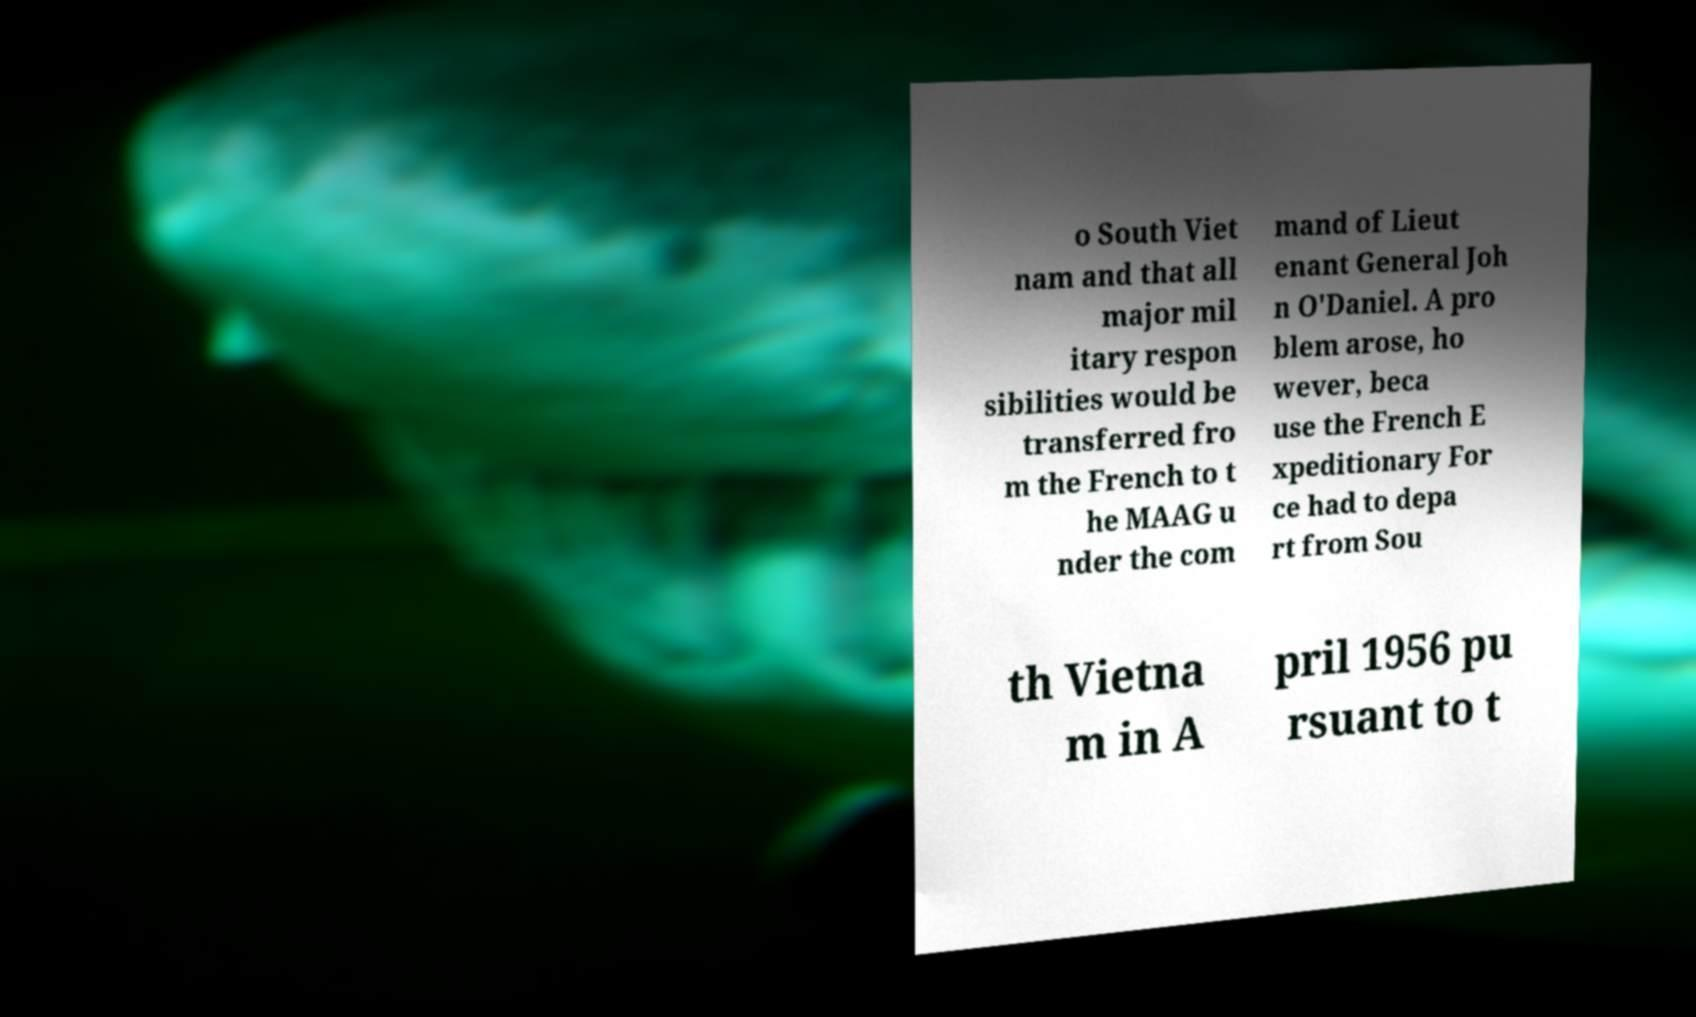Can you read and provide the text displayed in the image?This photo seems to have some interesting text. Can you extract and type it out for me? o South Viet nam and that all major mil itary respon sibilities would be transferred fro m the French to t he MAAG u nder the com mand of Lieut enant General Joh n O'Daniel. A pro blem arose, ho wever, beca use the French E xpeditionary For ce had to depa rt from Sou th Vietna m in A pril 1956 pu rsuant to t 